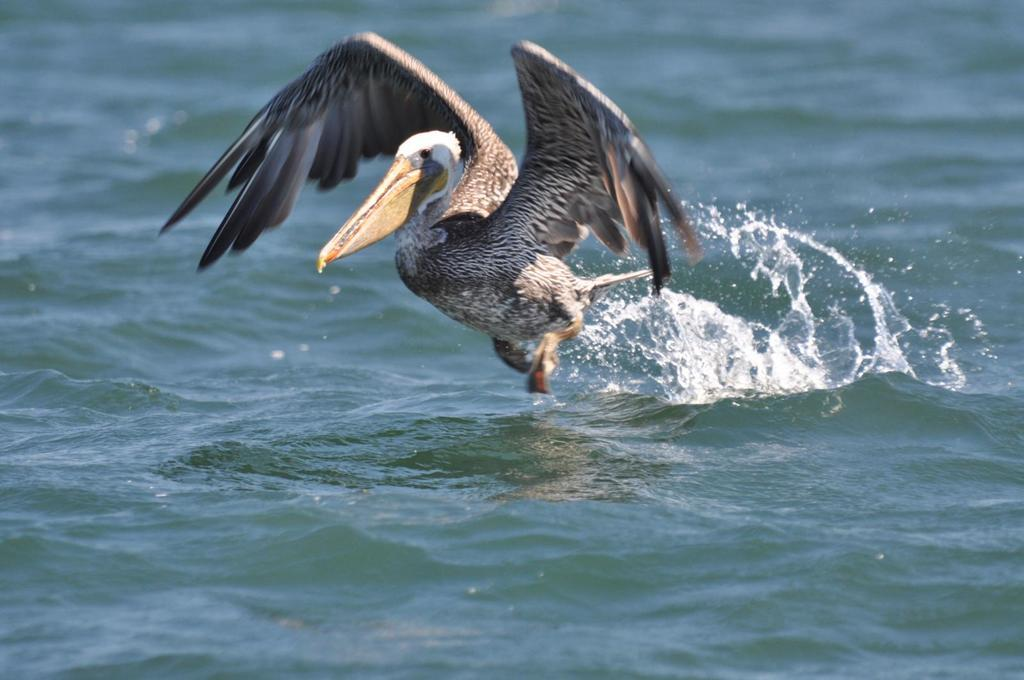What is the main subject of the image? There is a bird flying in the image. What is the primary element in the image? The image consists of water. Can you describe the quality of the image? The top part of the image is blurred. How many cattle can be seen grazing in the image? There are no cattle present in the image; it features a bird flying over water. What type of thrill can be experienced while observing the bird in the image? The image does not convey any specific thrill or emotion; it simply shows a bird flying over water. 